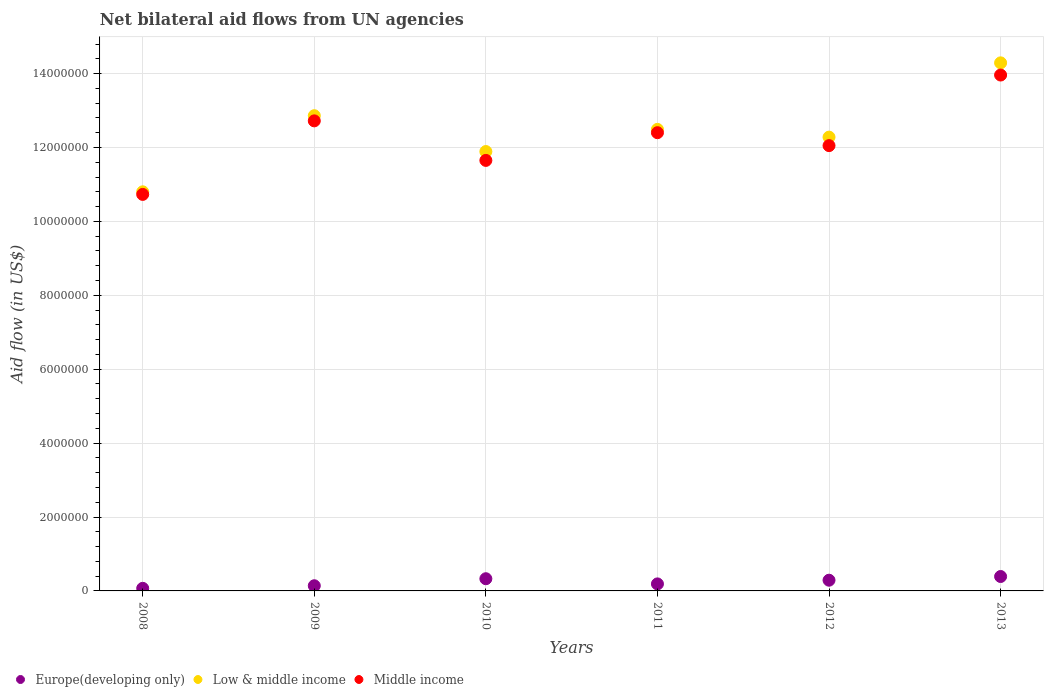How many different coloured dotlines are there?
Your answer should be compact. 3. Is the number of dotlines equal to the number of legend labels?
Your response must be concise. Yes. What is the net bilateral aid flow in Middle income in 2008?
Ensure brevity in your answer.  1.07e+07. Across all years, what is the maximum net bilateral aid flow in Middle income?
Make the answer very short. 1.40e+07. Across all years, what is the minimum net bilateral aid flow in Low & middle income?
Give a very brief answer. 1.08e+07. In which year was the net bilateral aid flow in Middle income minimum?
Provide a succinct answer. 2008. What is the total net bilateral aid flow in Europe(developing only) in the graph?
Offer a very short reply. 1.41e+06. What is the difference between the net bilateral aid flow in Low & middle income in 2008 and that in 2012?
Your answer should be very brief. -1.48e+06. What is the difference between the net bilateral aid flow in Middle income in 2013 and the net bilateral aid flow in Low & middle income in 2010?
Give a very brief answer. 2.07e+06. What is the average net bilateral aid flow in Europe(developing only) per year?
Ensure brevity in your answer.  2.35e+05. In the year 2009, what is the difference between the net bilateral aid flow in Europe(developing only) and net bilateral aid flow in Middle income?
Ensure brevity in your answer.  -1.26e+07. In how many years, is the net bilateral aid flow in Low & middle income greater than 8000000 US$?
Ensure brevity in your answer.  6. What is the ratio of the net bilateral aid flow in Middle income in 2008 to that in 2011?
Make the answer very short. 0.87. Is the net bilateral aid flow in Europe(developing only) in 2009 less than that in 2011?
Your response must be concise. Yes. What is the difference between the highest and the second highest net bilateral aid flow in Low & middle income?
Your answer should be very brief. 1.43e+06. What is the difference between the highest and the lowest net bilateral aid flow in Europe(developing only)?
Provide a succinct answer. 3.20e+05. Is the sum of the net bilateral aid flow in Low & middle income in 2009 and 2011 greater than the maximum net bilateral aid flow in Europe(developing only) across all years?
Your answer should be compact. Yes. Is the net bilateral aid flow in Middle income strictly less than the net bilateral aid flow in Europe(developing only) over the years?
Provide a succinct answer. No. How many dotlines are there?
Provide a short and direct response. 3. What is the difference between two consecutive major ticks on the Y-axis?
Offer a very short reply. 2.00e+06. Are the values on the major ticks of Y-axis written in scientific E-notation?
Your answer should be compact. No. Does the graph contain grids?
Offer a terse response. Yes. Where does the legend appear in the graph?
Your answer should be very brief. Bottom left. How are the legend labels stacked?
Provide a short and direct response. Horizontal. What is the title of the graph?
Provide a succinct answer. Net bilateral aid flows from UN agencies. Does "Albania" appear as one of the legend labels in the graph?
Your response must be concise. No. What is the label or title of the X-axis?
Make the answer very short. Years. What is the label or title of the Y-axis?
Offer a terse response. Aid flow (in US$). What is the Aid flow (in US$) of Low & middle income in 2008?
Offer a terse response. 1.08e+07. What is the Aid flow (in US$) in Middle income in 2008?
Provide a short and direct response. 1.07e+07. What is the Aid flow (in US$) in Europe(developing only) in 2009?
Your answer should be very brief. 1.40e+05. What is the Aid flow (in US$) of Low & middle income in 2009?
Provide a succinct answer. 1.29e+07. What is the Aid flow (in US$) of Middle income in 2009?
Offer a terse response. 1.27e+07. What is the Aid flow (in US$) in Europe(developing only) in 2010?
Give a very brief answer. 3.30e+05. What is the Aid flow (in US$) of Low & middle income in 2010?
Provide a short and direct response. 1.19e+07. What is the Aid flow (in US$) in Middle income in 2010?
Make the answer very short. 1.16e+07. What is the Aid flow (in US$) of Europe(developing only) in 2011?
Offer a terse response. 1.90e+05. What is the Aid flow (in US$) in Low & middle income in 2011?
Offer a very short reply. 1.25e+07. What is the Aid flow (in US$) of Middle income in 2011?
Provide a succinct answer. 1.24e+07. What is the Aid flow (in US$) in Europe(developing only) in 2012?
Your response must be concise. 2.90e+05. What is the Aid flow (in US$) of Low & middle income in 2012?
Your answer should be very brief. 1.23e+07. What is the Aid flow (in US$) of Middle income in 2012?
Your response must be concise. 1.20e+07. What is the Aid flow (in US$) of Low & middle income in 2013?
Your answer should be very brief. 1.43e+07. What is the Aid flow (in US$) in Middle income in 2013?
Ensure brevity in your answer.  1.40e+07. Across all years, what is the maximum Aid flow (in US$) in Europe(developing only)?
Offer a terse response. 3.90e+05. Across all years, what is the maximum Aid flow (in US$) in Low & middle income?
Ensure brevity in your answer.  1.43e+07. Across all years, what is the maximum Aid flow (in US$) of Middle income?
Keep it short and to the point. 1.40e+07. Across all years, what is the minimum Aid flow (in US$) of Europe(developing only)?
Provide a short and direct response. 7.00e+04. Across all years, what is the minimum Aid flow (in US$) of Low & middle income?
Offer a very short reply. 1.08e+07. Across all years, what is the minimum Aid flow (in US$) in Middle income?
Keep it short and to the point. 1.07e+07. What is the total Aid flow (in US$) of Europe(developing only) in the graph?
Provide a succinct answer. 1.41e+06. What is the total Aid flow (in US$) in Low & middle income in the graph?
Offer a very short reply. 7.46e+07. What is the total Aid flow (in US$) in Middle income in the graph?
Make the answer very short. 7.35e+07. What is the difference between the Aid flow (in US$) in Low & middle income in 2008 and that in 2009?
Your answer should be very brief. -2.06e+06. What is the difference between the Aid flow (in US$) in Middle income in 2008 and that in 2009?
Keep it short and to the point. -1.99e+06. What is the difference between the Aid flow (in US$) in Low & middle income in 2008 and that in 2010?
Your answer should be compact. -1.09e+06. What is the difference between the Aid flow (in US$) of Middle income in 2008 and that in 2010?
Your response must be concise. -9.20e+05. What is the difference between the Aid flow (in US$) in Low & middle income in 2008 and that in 2011?
Provide a succinct answer. -1.69e+06. What is the difference between the Aid flow (in US$) in Middle income in 2008 and that in 2011?
Your answer should be compact. -1.67e+06. What is the difference between the Aid flow (in US$) in Low & middle income in 2008 and that in 2012?
Make the answer very short. -1.48e+06. What is the difference between the Aid flow (in US$) in Middle income in 2008 and that in 2012?
Offer a very short reply. -1.32e+06. What is the difference between the Aid flow (in US$) of Europe(developing only) in 2008 and that in 2013?
Make the answer very short. -3.20e+05. What is the difference between the Aid flow (in US$) in Low & middle income in 2008 and that in 2013?
Your answer should be very brief. -3.49e+06. What is the difference between the Aid flow (in US$) of Middle income in 2008 and that in 2013?
Ensure brevity in your answer.  -3.23e+06. What is the difference between the Aid flow (in US$) in Low & middle income in 2009 and that in 2010?
Make the answer very short. 9.70e+05. What is the difference between the Aid flow (in US$) in Middle income in 2009 and that in 2010?
Your answer should be very brief. 1.07e+06. What is the difference between the Aid flow (in US$) of Middle income in 2009 and that in 2011?
Your answer should be very brief. 3.20e+05. What is the difference between the Aid flow (in US$) of Europe(developing only) in 2009 and that in 2012?
Give a very brief answer. -1.50e+05. What is the difference between the Aid flow (in US$) in Low & middle income in 2009 and that in 2012?
Make the answer very short. 5.80e+05. What is the difference between the Aid flow (in US$) of Middle income in 2009 and that in 2012?
Give a very brief answer. 6.70e+05. What is the difference between the Aid flow (in US$) in Europe(developing only) in 2009 and that in 2013?
Ensure brevity in your answer.  -2.50e+05. What is the difference between the Aid flow (in US$) in Low & middle income in 2009 and that in 2013?
Ensure brevity in your answer.  -1.43e+06. What is the difference between the Aid flow (in US$) in Middle income in 2009 and that in 2013?
Your answer should be compact. -1.24e+06. What is the difference between the Aid flow (in US$) of Low & middle income in 2010 and that in 2011?
Provide a succinct answer. -6.00e+05. What is the difference between the Aid flow (in US$) in Middle income in 2010 and that in 2011?
Offer a terse response. -7.50e+05. What is the difference between the Aid flow (in US$) in Low & middle income in 2010 and that in 2012?
Ensure brevity in your answer.  -3.90e+05. What is the difference between the Aid flow (in US$) of Middle income in 2010 and that in 2012?
Ensure brevity in your answer.  -4.00e+05. What is the difference between the Aid flow (in US$) in Low & middle income in 2010 and that in 2013?
Provide a succinct answer. -2.40e+06. What is the difference between the Aid flow (in US$) of Middle income in 2010 and that in 2013?
Make the answer very short. -2.31e+06. What is the difference between the Aid flow (in US$) of Europe(developing only) in 2011 and that in 2012?
Provide a succinct answer. -1.00e+05. What is the difference between the Aid flow (in US$) of Europe(developing only) in 2011 and that in 2013?
Make the answer very short. -2.00e+05. What is the difference between the Aid flow (in US$) of Low & middle income in 2011 and that in 2013?
Ensure brevity in your answer.  -1.80e+06. What is the difference between the Aid flow (in US$) of Middle income in 2011 and that in 2013?
Make the answer very short. -1.56e+06. What is the difference between the Aid flow (in US$) in Low & middle income in 2012 and that in 2013?
Ensure brevity in your answer.  -2.01e+06. What is the difference between the Aid flow (in US$) of Middle income in 2012 and that in 2013?
Ensure brevity in your answer.  -1.91e+06. What is the difference between the Aid flow (in US$) in Europe(developing only) in 2008 and the Aid flow (in US$) in Low & middle income in 2009?
Your response must be concise. -1.28e+07. What is the difference between the Aid flow (in US$) of Europe(developing only) in 2008 and the Aid flow (in US$) of Middle income in 2009?
Offer a terse response. -1.26e+07. What is the difference between the Aid flow (in US$) of Low & middle income in 2008 and the Aid flow (in US$) of Middle income in 2009?
Offer a terse response. -1.92e+06. What is the difference between the Aid flow (in US$) in Europe(developing only) in 2008 and the Aid flow (in US$) in Low & middle income in 2010?
Offer a terse response. -1.18e+07. What is the difference between the Aid flow (in US$) in Europe(developing only) in 2008 and the Aid flow (in US$) in Middle income in 2010?
Offer a terse response. -1.16e+07. What is the difference between the Aid flow (in US$) in Low & middle income in 2008 and the Aid flow (in US$) in Middle income in 2010?
Provide a succinct answer. -8.50e+05. What is the difference between the Aid flow (in US$) of Europe(developing only) in 2008 and the Aid flow (in US$) of Low & middle income in 2011?
Keep it short and to the point. -1.24e+07. What is the difference between the Aid flow (in US$) of Europe(developing only) in 2008 and the Aid flow (in US$) of Middle income in 2011?
Offer a terse response. -1.23e+07. What is the difference between the Aid flow (in US$) in Low & middle income in 2008 and the Aid flow (in US$) in Middle income in 2011?
Your answer should be very brief. -1.60e+06. What is the difference between the Aid flow (in US$) of Europe(developing only) in 2008 and the Aid flow (in US$) of Low & middle income in 2012?
Offer a very short reply. -1.22e+07. What is the difference between the Aid flow (in US$) of Europe(developing only) in 2008 and the Aid flow (in US$) of Middle income in 2012?
Make the answer very short. -1.20e+07. What is the difference between the Aid flow (in US$) of Low & middle income in 2008 and the Aid flow (in US$) of Middle income in 2012?
Make the answer very short. -1.25e+06. What is the difference between the Aid flow (in US$) of Europe(developing only) in 2008 and the Aid flow (in US$) of Low & middle income in 2013?
Your response must be concise. -1.42e+07. What is the difference between the Aid flow (in US$) in Europe(developing only) in 2008 and the Aid flow (in US$) in Middle income in 2013?
Provide a succinct answer. -1.39e+07. What is the difference between the Aid flow (in US$) of Low & middle income in 2008 and the Aid flow (in US$) of Middle income in 2013?
Offer a terse response. -3.16e+06. What is the difference between the Aid flow (in US$) of Europe(developing only) in 2009 and the Aid flow (in US$) of Low & middle income in 2010?
Your response must be concise. -1.18e+07. What is the difference between the Aid flow (in US$) in Europe(developing only) in 2009 and the Aid flow (in US$) in Middle income in 2010?
Your answer should be very brief. -1.15e+07. What is the difference between the Aid flow (in US$) of Low & middle income in 2009 and the Aid flow (in US$) of Middle income in 2010?
Ensure brevity in your answer.  1.21e+06. What is the difference between the Aid flow (in US$) of Europe(developing only) in 2009 and the Aid flow (in US$) of Low & middle income in 2011?
Offer a very short reply. -1.24e+07. What is the difference between the Aid flow (in US$) in Europe(developing only) in 2009 and the Aid flow (in US$) in Middle income in 2011?
Provide a short and direct response. -1.23e+07. What is the difference between the Aid flow (in US$) in Europe(developing only) in 2009 and the Aid flow (in US$) in Low & middle income in 2012?
Your response must be concise. -1.21e+07. What is the difference between the Aid flow (in US$) of Europe(developing only) in 2009 and the Aid flow (in US$) of Middle income in 2012?
Make the answer very short. -1.19e+07. What is the difference between the Aid flow (in US$) in Low & middle income in 2009 and the Aid flow (in US$) in Middle income in 2012?
Give a very brief answer. 8.10e+05. What is the difference between the Aid flow (in US$) in Europe(developing only) in 2009 and the Aid flow (in US$) in Low & middle income in 2013?
Your answer should be compact. -1.42e+07. What is the difference between the Aid flow (in US$) in Europe(developing only) in 2009 and the Aid flow (in US$) in Middle income in 2013?
Provide a succinct answer. -1.38e+07. What is the difference between the Aid flow (in US$) of Low & middle income in 2009 and the Aid flow (in US$) of Middle income in 2013?
Your response must be concise. -1.10e+06. What is the difference between the Aid flow (in US$) in Europe(developing only) in 2010 and the Aid flow (in US$) in Low & middle income in 2011?
Ensure brevity in your answer.  -1.22e+07. What is the difference between the Aid flow (in US$) of Europe(developing only) in 2010 and the Aid flow (in US$) of Middle income in 2011?
Provide a short and direct response. -1.21e+07. What is the difference between the Aid flow (in US$) in Low & middle income in 2010 and the Aid flow (in US$) in Middle income in 2011?
Your answer should be very brief. -5.10e+05. What is the difference between the Aid flow (in US$) in Europe(developing only) in 2010 and the Aid flow (in US$) in Low & middle income in 2012?
Offer a terse response. -1.20e+07. What is the difference between the Aid flow (in US$) in Europe(developing only) in 2010 and the Aid flow (in US$) in Middle income in 2012?
Your answer should be compact. -1.17e+07. What is the difference between the Aid flow (in US$) in Low & middle income in 2010 and the Aid flow (in US$) in Middle income in 2012?
Offer a terse response. -1.60e+05. What is the difference between the Aid flow (in US$) of Europe(developing only) in 2010 and the Aid flow (in US$) of Low & middle income in 2013?
Offer a terse response. -1.40e+07. What is the difference between the Aid flow (in US$) in Europe(developing only) in 2010 and the Aid flow (in US$) in Middle income in 2013?
Provide a short and direct response. -1.36e+07. What is the difference between the Aid flow (in US$) of Low & middle income in 2010 and the Aid flow (in US$) of Middle income in 2013?
Provide a succinct answer. -2.07e+06. What is the difference between the Aid flow (in US$) of Europe(developing only) in 2011 and the Aid flow (in US$) of Low & middle income in 2012?
Provide a succinct answer. -1.21e+07. What is the difference between the Aid flow (in US$) of Europe(developing only) in 2011 and the Aid flow (in US$) of Middle income in 2012?
Keep it short and to the point. -1.19e+07. What is the difference between the Aid flow (in US$) in Low & middle income in 2011 and the Aid flow (in US$) in Middle income in 2012?
Provide a short and direct response. 4.40e+05. What is the difference between the Aid flow (in US$) of Europe(developing only) in 2011 and the Aid flow (in US$) of Low & middle income in 2013?
Provide a short and direct response. -1.41e+07. What is the difference between the Aid flow (in US$) of Europe(developing only) in 2011 and the Aid flow (in US$) of Middle income in 2013?
Make the answer very short. -1.38e+07. What is the difference between the Aid flow (in US$) of Low & middle income in 2011 and the Aid flow (in US$) of Middle income in 2013?
Give a very brief answer. -1.47e+06. What is the difference between the Aid flow (in US$) of Europe(developing only) in 2012 and the Aid flow (in US$) of Low & middle income in 2013?
Offer a very short reply. -1.40e+07. What is the difference between the Aid flow (in US$) in Europe(developing only) in 2012 and the Aid flow (in US$) in Middle income in 2013?
Make the answer very short. -1.37e+07. What is the difference between the Aid flow (in US$) in Low & middle income in 2012 and the Aid flow (in US$) in Middle income in 2013?
Your answer should be compact. -1.68e+06. What is the average Aid flow (in US$) in Europe(developing only) per year?
Your response must be concise. 2.35e+05. What is the average Aid flow (in US$) of Low & middle income per year?
Give a very brief answer. 1.24e+07. What is the average Aid flow (in US$) of Middle income per year?
Offer a terse response. 1.23e+07. In the year 2008, what is the difference between the Aid flow (in US$) in Europe(developing only) and Aid flow (in US$) in Low & middle income?
Your answer should be very brief. -1.07e+07. In the year 2008, what is the difference between the Aid flow (in US$) in Europe(developing only) and Aid flow (in US$) in Middle income?
Your response must be concise. -1.07e+07. In the year 2008, what is the difference between the Aid flow (in US$) in Low & middle income and Aid flow (in US$) in Middle income?
Your answer should be compact. 7.00e+04. In the year 2009, what is the difference between the Aid flow (in US$) in Europe(developing only) and Aid flow (in US$) in Low & middle income?
Your answer should be compact. -1.27e+07. In the year 2009, what is the difference between the Aid flow (in US$) in Europe(developing only) and Aid flow (in US$) in Middle income?
Provide a short and direct response. -1.26e+07. In the year 2010, what is the difference between the Aid flow (in US$) of Europe(developing only) and Aid flow (in US$) of Low & middle income?
Provide a succinct answer. -1.16e+07. In the year 2010, what is the difference between the Aid flow (in US$) in Europe(developing only) and Aid flow (in US$) in Middle income?
Ensure brevity in your answer.  -1.13e+07. In the year 2011, what is the difference between the Aid flow (in US$) in Europe(developing only) and Aid flow (in US$) in Low & middle income?
Keep it short and to the point. -1.23e+07. In the year 2011, what is the difference between the Aid flow (in US$) in Europe(developing only) and Aid flow (in US$) in Middle income?
Keep it short and to the point. -1.22e+07. In the year 2012, what is the difference between the Aid flow (in US$) of Europe(developing only) and Aid flow (in US$) of Low & middle income?
Give a very brief answer. -1.20e+07. In the year 2012, what is the difference between the Aid flow (in US$) in Europe(developing only) and Aid flow (in US$) in Middle income?
Ensure brevity in your answer.  -1.18e+07. In the year 2012, what is the difference between the Aid flow (in US$) of Low & middle income and Aid flow (in US$) of Middle income?
Provide a short and direct response. 2.30e+05. In the year 2013, what is the difference between the Aid flow (in US$) of Europe(developing only) and Aid flow (in US$) of Low & middle income?
Give a very brief answer. -1.39e+07. In the year 2013, what is the difference between the Aid flow (in US$) of Europe(developing only) and Aid flow (in US$) of Middle income?
Keep it short and to the point. -1.36e+07. What is the ratio of the Aid flow (in US$) in Europe(developing only) in 2008 to that in 2009?
Your answer should be very brief. 0.5. What is the ratio of the Aid flow (in US$) of Low & middle income in 2008 to that in 2009?
Your response must be concise. 0.84. What is the ratio of the Aid flow (in US$) of Middle income in 2008 to that in 2009?
Provide a succinct answer. 0.84. What is the ratio of the Aid flow (in US$) of Europe(developing only) in 2008 to that in 2010?
Your response must be concise. 0.21. What is the ratio of the Aid flow (in US$) of Low & middle income in 2008 to that in 2010?
Make the answer very short. 0.91. What is the ratio of the Aid flow (in US$) of Middle income in 2008 to that in 2010?
Your answer should be very brief. 0.92. What is the ratio of the Aid flow (in US$) in Europe(developing only) in 2008 to that in 2011?
Give a very brief answer. 0.37. What is the ratio of the Aid flow (in US$) of Low & middle income in 2008 to that in 2011?
Your answer should be very brief. 0.86. What is the ratio of the Aid flow (in US$) of Middle income in 2008 to that in 2011?
Make the answer very short. 0.87. What is the ratio of the Aid flow (in US$) of Europe(developing only) in 2008 to that in 2012?
Make the answer very short. 0.24. What is the ratio of the Aid flow (in US$) of Low & middle income in 2008 to that in 2012?
Give a very brief answer. 0.88. What is the ratio of the Aid flow (in US$) of Middle income in 2008 to that in 2012?
Provide a succinct answer. 0.89. What is the ratio of the Aid flow (in US$) of Europe(developing only) in 2008 to that in 2013?
Your answer should be compact. 0.18. What is the ratio of the Aid flow (in US$) in Low & middle income in 2008 to that in 2013?
Offer a terse response. 0.76. What is the ratio of the Aid flow (in US$) of Middle income in 2008 to that in 2013?
Keep it short and to the point. 0.77. What is the ratio of the Aid flow (in US$) in Europe(developing only) in 2009 to that in 2010?
Your answer should be compact. 0.42. What is the ratio of the Aid flow (in US$) in Low & middle income in 2009 to that in 2010?
Your answer should be compact. 1.08. What is the ratio of the Aid flow (in US$) of Middle income in 2009 to that in 2010?
Offer a terse response. 1.09. What is the ratio of the Aid flow (in US$) in Europe(developing only) in 2009 to that in 2011?
Keep it short and to the point. 0.74. What is the ratio of the Aid flow (in US$) in Low & middle income in 2009 to that in 2011?
Give a very brief answer. 1.03. What is the ratio of the Aid flow (in US$) in Middle income in 2009 to that in 2011?
Offer a terse response. 1.03. What is the ratio of the Aid flow (in US$) in Europe(developing only) in 2009 to that in 2012?
Give a very brief answer. 0.48. What is the ratio of the Aid flow (in US$) in Low & middle income in 2009 to that in 2012?
Keep it short and to the point. 1.05. What is the ratio of the Aid flow (in US$) of Middle income in 2009 to that in 2012?
Your answer should be very brief. 1.06. What is the ratio of the Aid flow (in US$) in Europe(developing only) in 2009 to that in 2013?
Keep it short and to the point. 0.36. What is the ratio of the Aid flow (in US$) in Low & middle income in 2009 to that in 2013?
Your answer should be compact. 0.9. What is the ratio of the Aid flow (in US$) of Middle income in 2009 to that in 2013?
Make the answer very short. 0.91. What is the ratio of the Aid flow (in US$) in Europe(developing only) in 2010 to that in 2011?
Offer a very short reply. 1.74. What is the ratio of the Aid flow (in US$) in Low & middle income in 2010 to that in 2011?
Give a very brief answer. 0.95. What is the ratio of the Aid flow (in US$) in Middle income in 2010 to that in 2011?
Make the answer very short. 0.94. What is the ratio of the Aid flow (in US$) of Europe(developing only) in 2010 to that in 2012?
Give a very brief answer. 1.14. What is the ratio of the Aid flow (in US$) in Low & middle income in 2010 to that in 2012?
Provide a short and direct response. 0.97. What is the ratio of the Aid flow (in US$) in Middle income in 2010 to that in 2012?
Ensure brevity in your answer.  0.97. What is the ratio of the Aid flow (in US$) of Europe(developing only) in 2010 to that in 2013?
Ensure brevity in your answer.  0.85. What is the ratio of the Aid flow (in US$) in Low & middle income in 2010 to that in 2013?
Provide a short and direct response. 0.83. What is the ratio of the Aid flow (in US$) in Middle income in 2010 to that in 2013?
Make the answer very short. 0.83. What is the ratio of the Aid flow (in US$) of Europe(developing only) in 2011 to that in 2012?
Make the answer very short. 0.66. What is the ratio of the Aid flow (in US$) in Low & middle income in 2011 to that in 2012?
Keep it short and to the point. 1.02. What is the ratio of the Aid flow (in US$) of Europe(developing only) in 2011 to that in 2013?
Offer a terse response. 0.49. What is the ratio of the Aid flow (in US$) of Low & middle income in 2011 to that in 2013?
Your answer should be very brief. 0.87. What is the ratio of the Aid flow (in US$) of Middle income in 2011 to that in 2013?
Offer a very short reply. 0.89. What is the ratio of the Aid flow (in US$) of Europe(developing only) in 2012 to that in 2013?
Your answer should be compact. 0.74. What is the ratio of the Aid flow (in US$) in Low & middle income in 2012 to that in 2013?
Your answer should be compact. 0.86. What is the ratio of the Aid flow (in US$) of Middle income in 2012 to that in 2013?
Provide a succinct answer. 0.86. What is the difference between the highest and the second highest Aid flow (in US$) in Europe(developing only)?
Your answer should be very brief. 6.00e+04. What is the difference between the highest and the second highest Aid flow (in US$) of Low & middle income?
Your answer should be compact. 1.43e+06. What is the difference between the highest and the second highest Aid flow (in US$) of Middle income?
Your response must be concise. 1.24e+06. What is the difference between the highest and the lowest Aid flow (in US$) of Low & middle income?
Keep it short and to the point. 3.49e+06. What is the difference between the highest and the lowest Aid flow (in US$) in Middle income?
Your answer should be compact. 3.23e+06. 